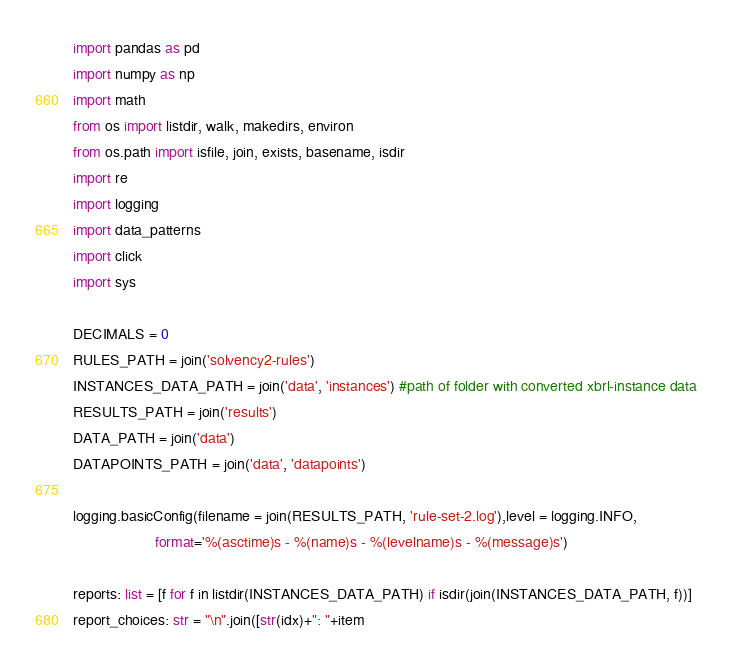<code> <loc_0><loc_0><loc_500><loc_500><_Python_>import pandas as pd
import numpy as np
import math
from os import listdir, walk, makedirs, environ
from os.path import isfile, join, exists, basename, isdir
import re
import logging
import data_patterns
import click
import sys

DECIMALS = 0
RULES_PATH = join('solvency2-rules')
INSTANCES_DATA_PATH = join('data', 'instances') #path of folder with converted xbrl-instance data
RESULTS_PATH = join('results')
DATA_PATH = join('data')
DATAPOINTS_PATH = join('data', 'datapoints')

logging.basicConfig(filename = join(RESULTS_PATH, 'rule-set-2.log'),level = logging.INFO, 
                    format='%(asctime)s - %(name)s - %(levelname)s - %(message)s')

reports: list = [f for f in listdir(INSTANCES_DATA_PATH) if isdir(join(INSTANCES_DATA_PATH, f))]
report_choices: str = "\n".join([str(idx)+": "+item</code> 